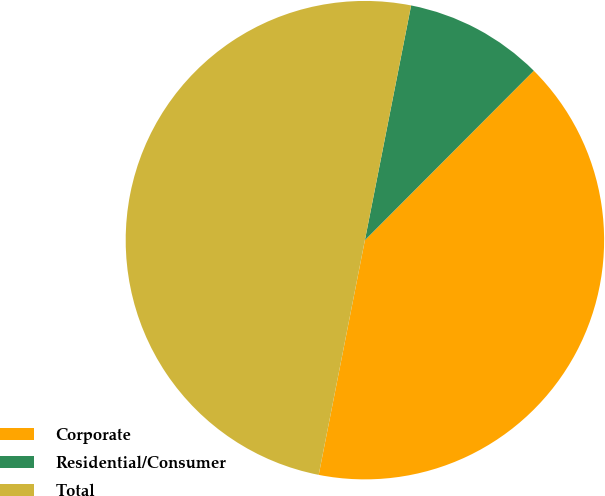<chart> <loc_0><loc_0><loc_500><loc_500><pie_chart><fcel>Corporate<fcel>Residential/Consumer<fcel>Total<nl><fcel>40.62%<fcel>9.38%<fcel>50.0%<nl></chart> 